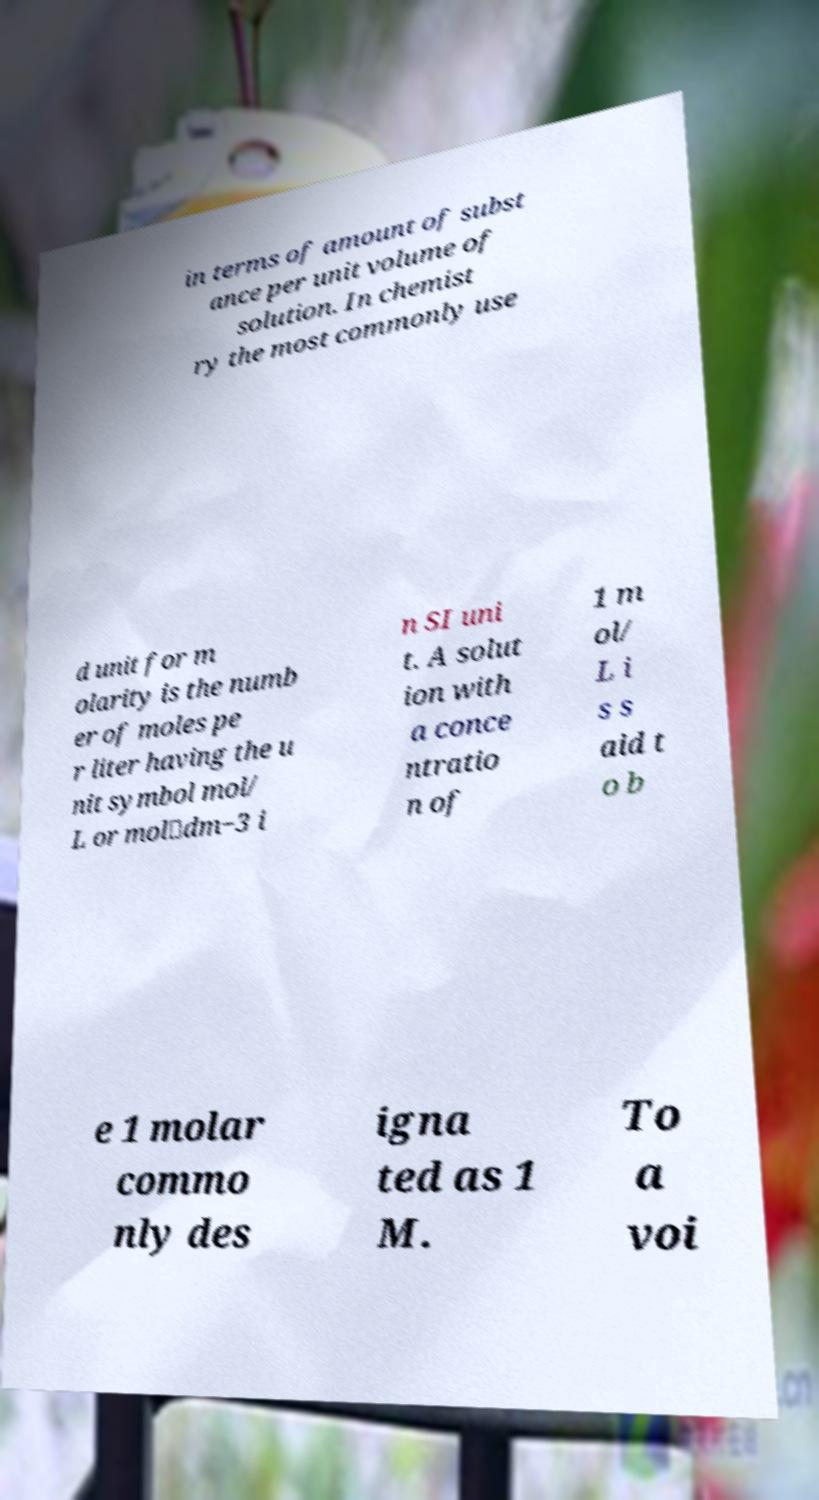Can you accurately transcribe the text from the provided image for me? in terms of amount of subst ance per unit volume of solution. In chemist ry the most commonly use d unit for m olarity is the numb er of moles pe r liter having the u nit symbol mol/ L or mol⋅dm−3 i n SI uni t. A solut ion with a conce ntratio n of 1 m ol/ L i s s aid t o b e 1 molar commo nly des igna ted as 1 M. To a voi 